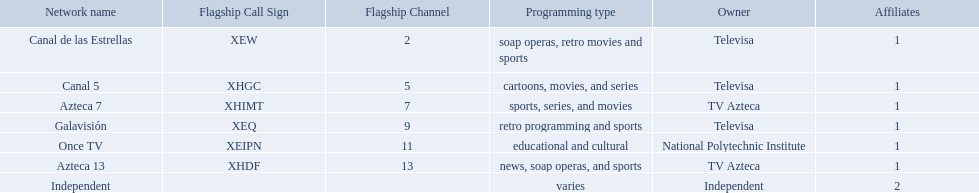Which owner only owns one network? National Polytechnic Institute, Independent. Of those, what is the network name? Once TV, Independent. Of those, which programming type is educational and cultural? Once TV. 